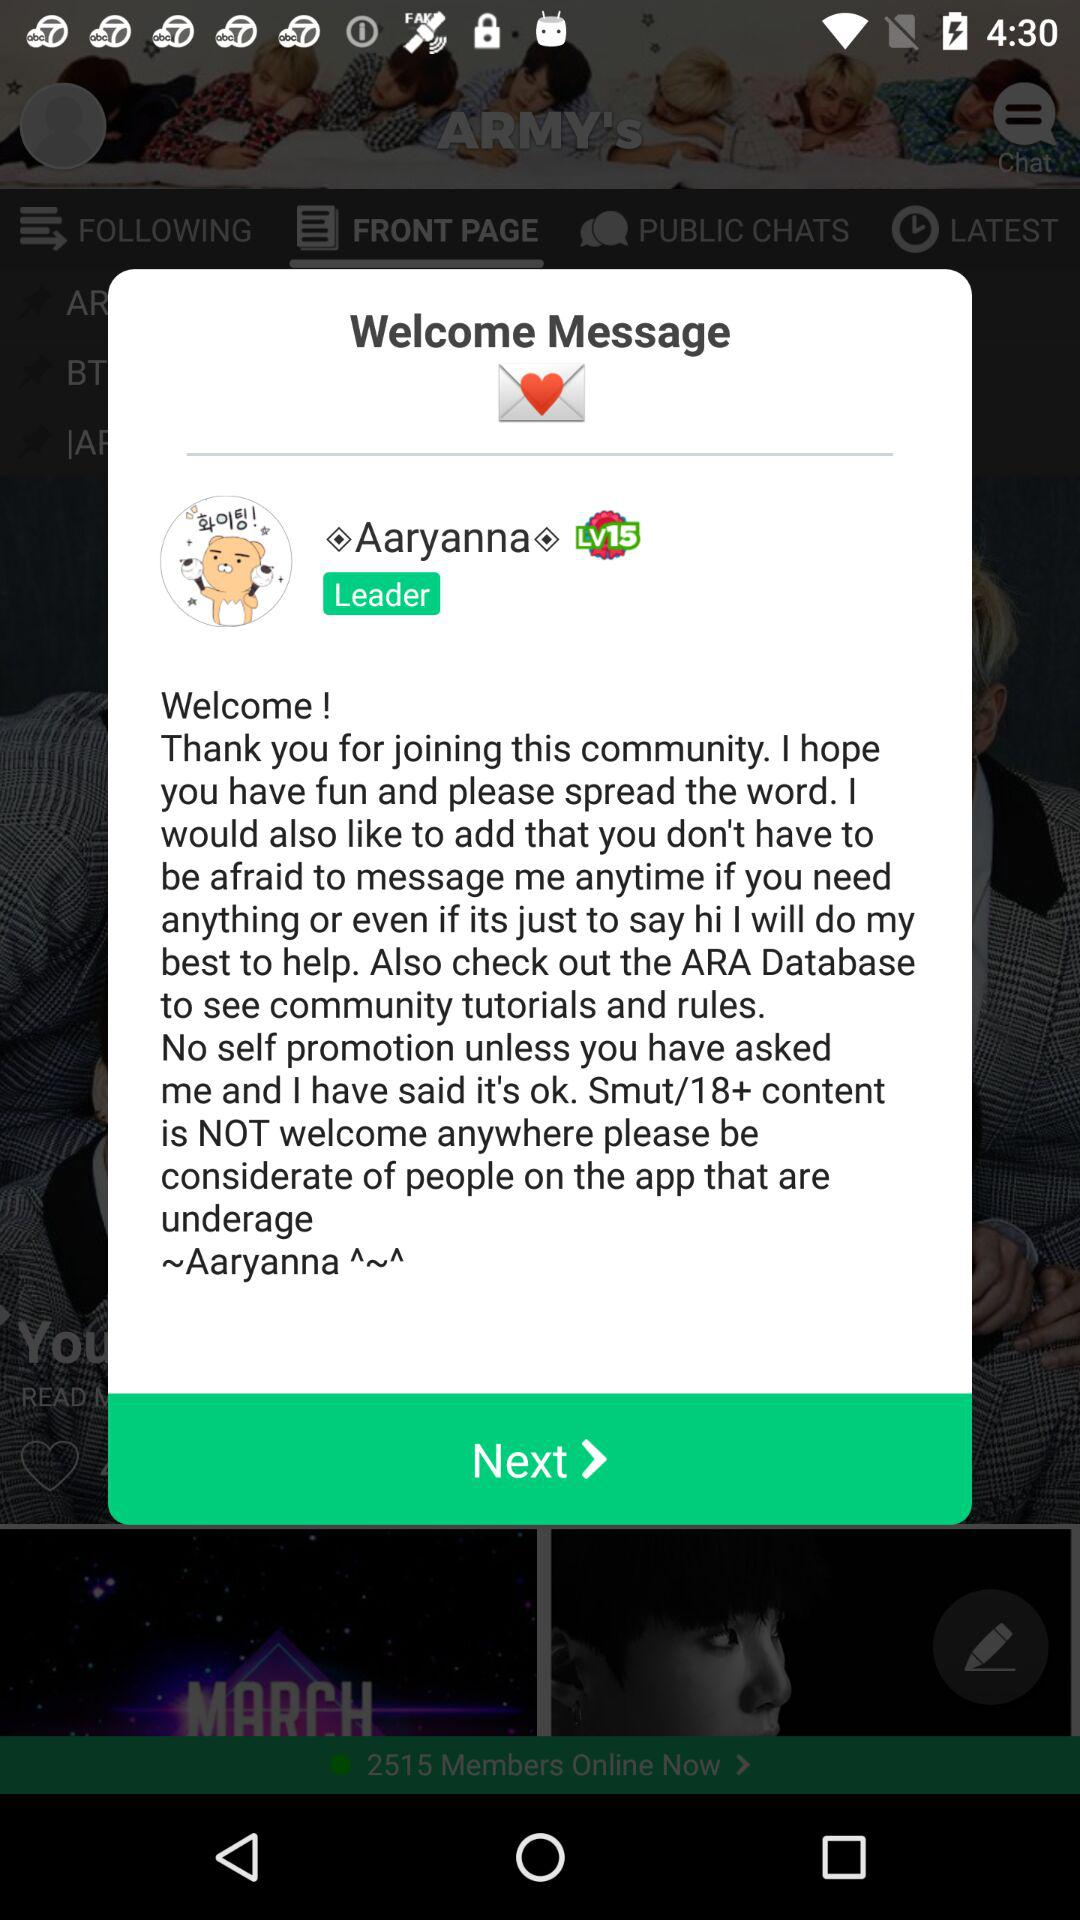What is the name of the leader? The name of the leader is Aaryanna. 